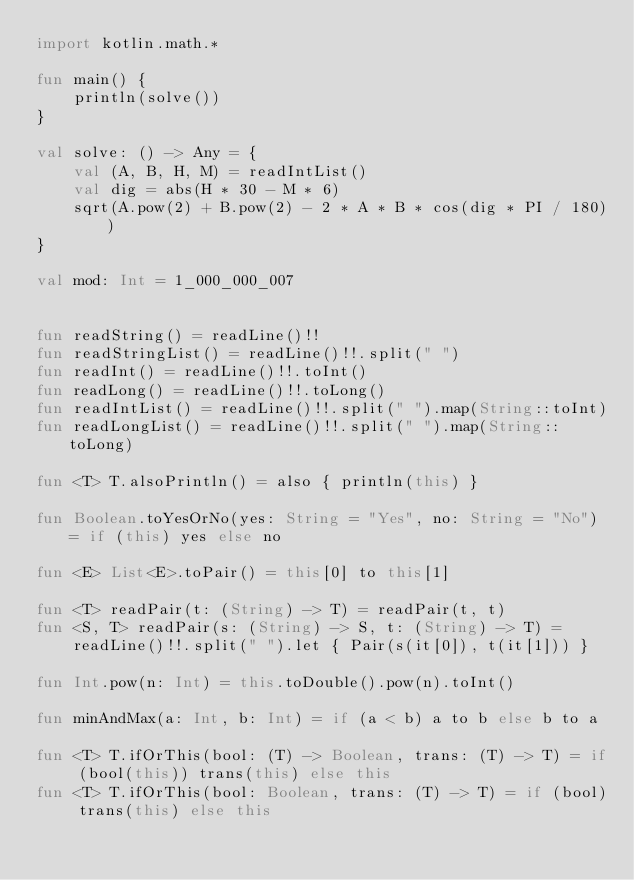Convert code to text. <code><loc_0><loc_0><loc_500><loc_500><_Kotlin_>import kotlin.math.*

fun main() {
    println(solve())
}

val solve: () -> Any = {
    val (A, B, H, M) = readIntList()
    val dig = abs(H * 30 - M * 6)
    sqrt(A.pow(2) + B.pow(2) - 2 * A * B * cos(dig * PI / 180))
}

val mod: Int = 1_000_000_007


fun readString() = readLine()!!
fun readStringList() = readLine()!!.split(" ")
fun readInt() = readLine()!!.toInt()
fun readLong() = readLine()!!.toLong()
fun readIntList() = readLine()!!.split(" ").map(String::toInt)
fun readLongList() = readLine()!!.split(" ").map(String::toLong)

fun <T> T.alsoPrintln() = also { println(this) }

fun Boolean.toYesOrNo(yes: String = "Yes", no: String = "No") = if (this) yes else no

fun <E> List<E>.toPair() = this[0] to this[1]

fun <T> readPair(t: (String) -> T) = readPair(t, t)
fun <S, T> readPair(s: (String) -> S, t: (String) -> T) =
    readLine()!!.split(" ").let { Pair(s(it[0]), t(it[1])) }

fun Int.pow(n: Int) = this.toDouble().pow(n).toInt()

fun minAndMax(a: Int, b: Int) = if (a < b) a to b else b to a

fun <T> T.ifOrThis(bool: (T) -> Boolean, trans: (T) -> T) = if (bool(this)) trans(this) else this
fun <T> T.ifOrThis(bool: Boolean, trans: (T) -> T) = if (bool) trans(this) else this</code> 